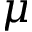Convert formula to latex. <formula><loc_0><loc_0><loc_500><loc_500>\mu</formula> 